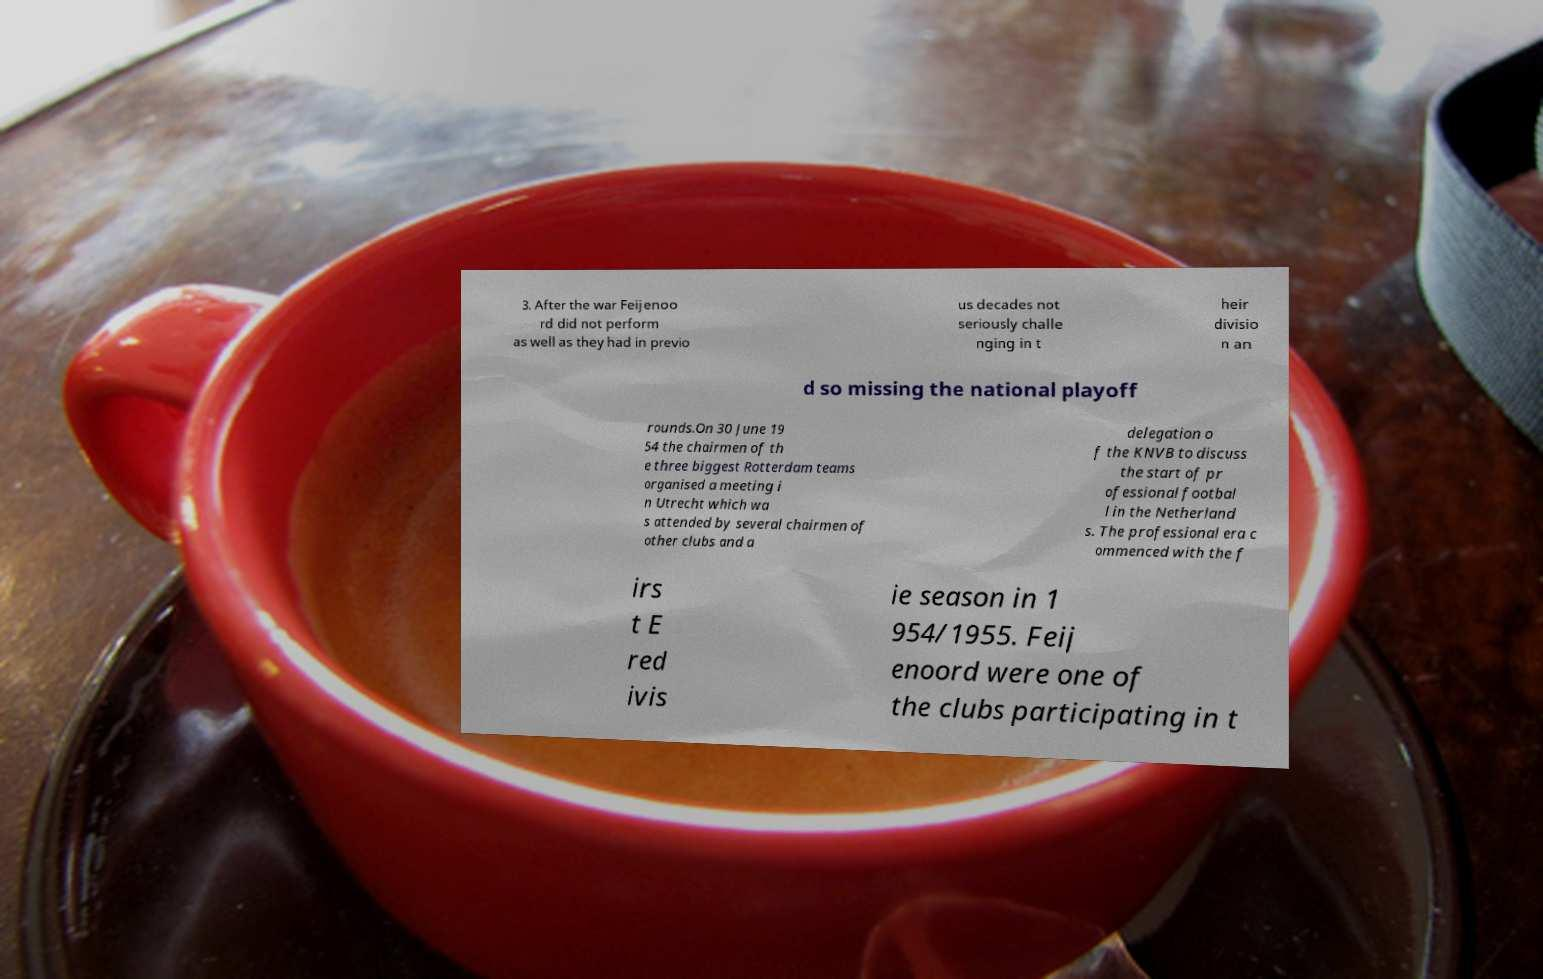Could you extract and type out the text from this image? 3. After the war Feijenoo rd did not perform as well as they had in previo us decades not seriously challe nging in t heir divisio n an d so missing the national playoff rounds.On 30 June 19 54 the chairmen of th e three biggest Rotterdam teams organised a meeting i n Utrecht which wa s attended by several chairmen of other clubs and a delegation o f the KNVB to discuss the start of pr ofessional footbal l in the Netherland s. The professional era c ommenced with the f irs t E red ivis ie season in 1 954/1955. Feij enoord were one of the clubs participating in t 